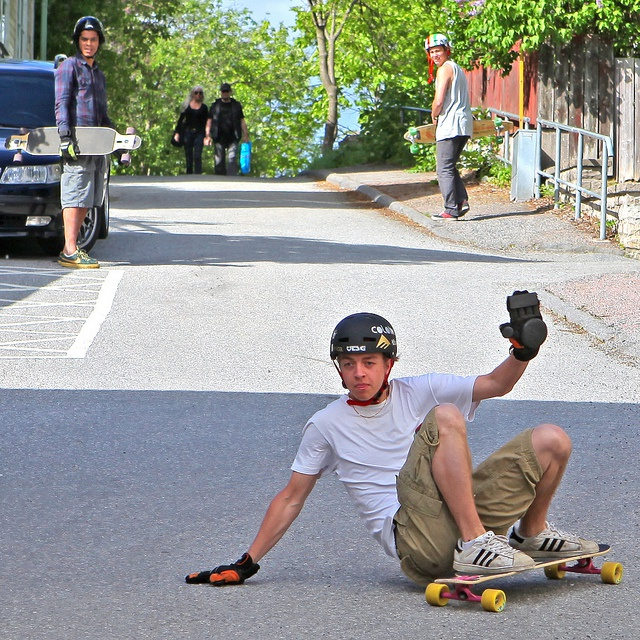Describe the objects in this image and their specific colors. I can see people in gray, darkgray, and black tones, car in gray, black, navy, and darkgray tones, people in gray, black, and lightgray tones, people in gray, white, darkgray, and black tones, and skateboard in gray, black, maroon, and olive tones in this image. 